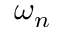Convert formula to latex. <formula><loc_0><loc_0><loc_500><loc_500>\omega _ { n }</formula> 